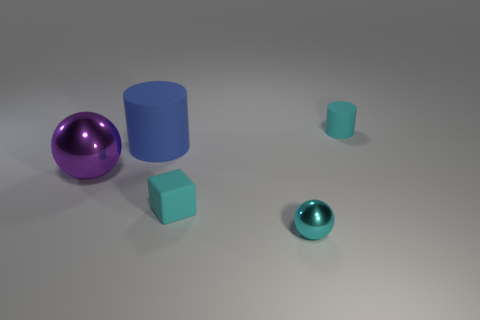Is the color of the tiny rubber block the same as the tiny shiny sphere? yes 